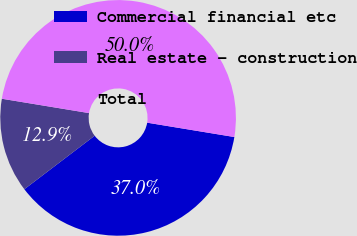<chart> <loc_0><loc_0><loc_500><loc_500><pie_chart><fcel>Commercial financial etc<fcel>Real estate - construction<fcel>Total<nl><fcel>37.05%<fcel>12.95%<fcel>50.0%<nl></chart> 